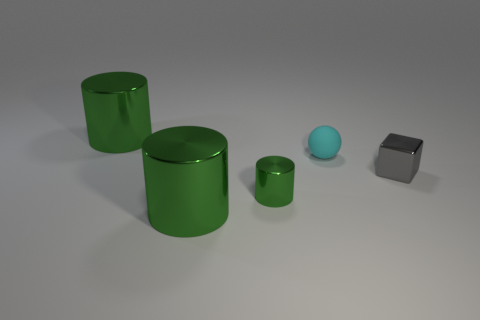How many green cylinders must be subtracted to get 2 green cylinders? 1 Add 1 green cylinders. How many objects exist? 6 Subtract all small shiny cylinders. How many cylinders are left? 2 Add 5 large things. How many large things exist? 7 Subtract 1 gray cubes. How many objects are left? 4 Subtract all spheres. How many objects are left? 4 Subtract all red cylinders. Subtract all red cubes. How many cylinders are left? 3 Subtract all tiny gray metallic things. Subtract all cyan objects. How many objects are left? 3 Add 2 big green cylinders. How many big green cylinders are left? 4 